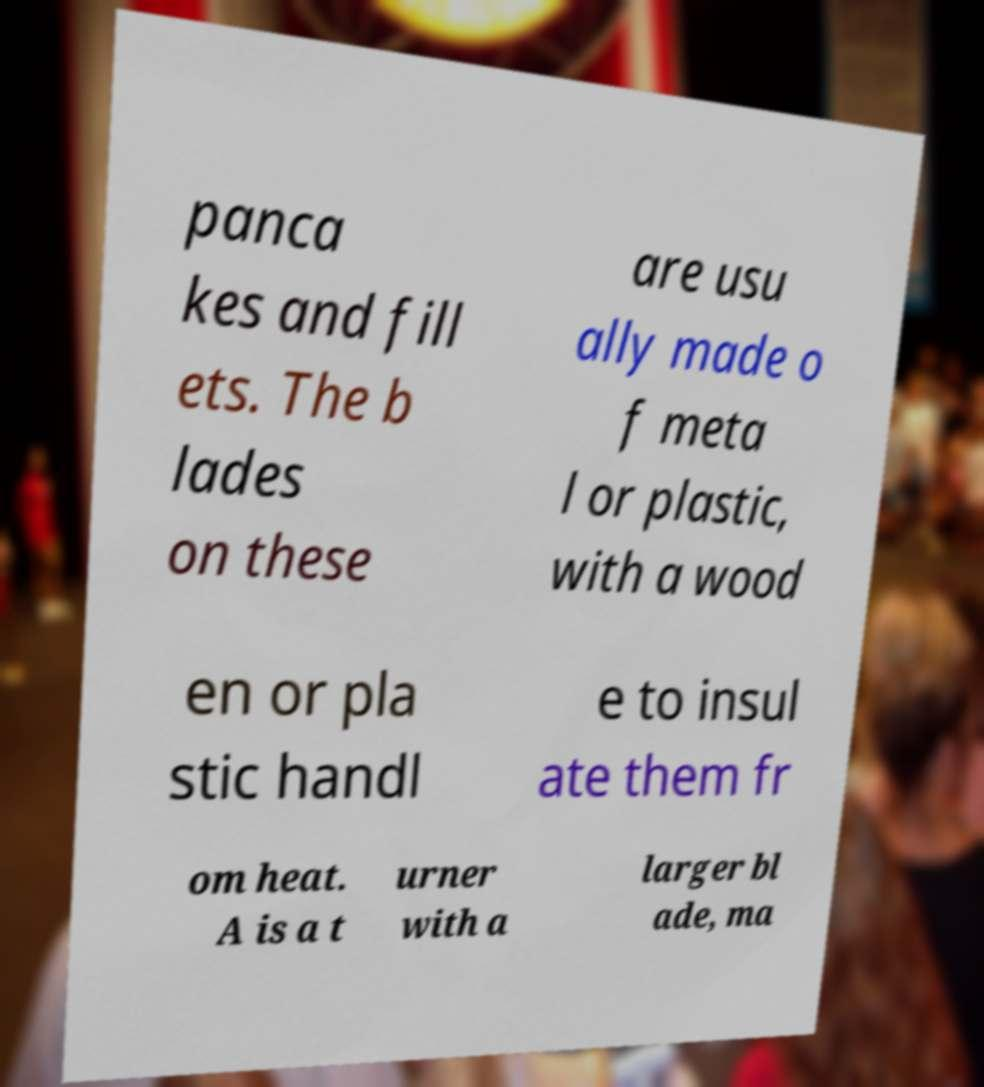Could you assist in decoding the text presented in this image and type it out clearly? panca kes and fill ets. The b lades on these are usu ally made o f meta l or plastic, with a wood en or pla stic handl e to insul ate them fr om heat. A is a t urner with a larger bl ade, ma 